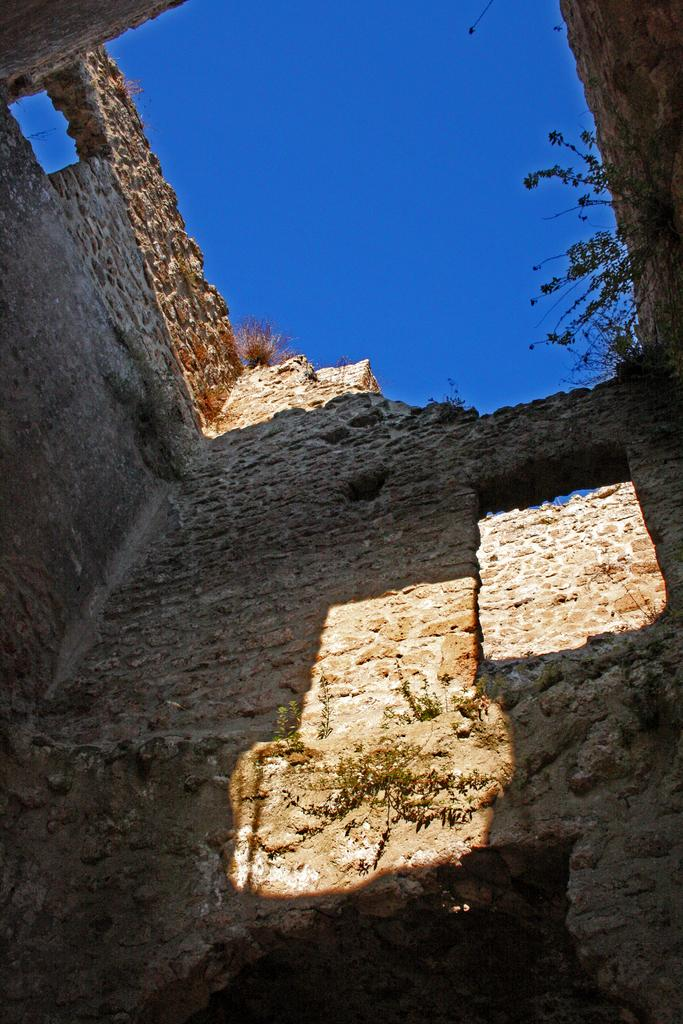What is the main subject of the image? The main subject of the image is the walls of a building. Are there any natural elements present in the image? Yes, there are plants visible in the image. How would you describe the condition of the grass in the image? The grass appears to be dried in the image. What can be seen in the background of the image? The sky is visible in the image. How does the cub interact with the deer in the image? There are no cubs or deer present in the image; it only shows the walls of a building, plants, dried grass, and the sky. 